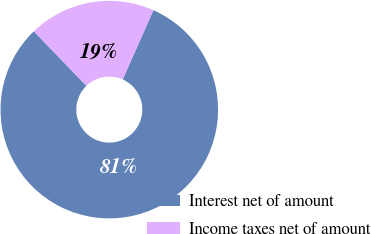Convert chart. <chart><loc_0><loc_0><loc_500><loc_500><pie_chart><fcel>Interest net of amount<fcel>Income taxes net of amount<nl><fcel>81.15%<fcel>18.85%<nl></chart> 